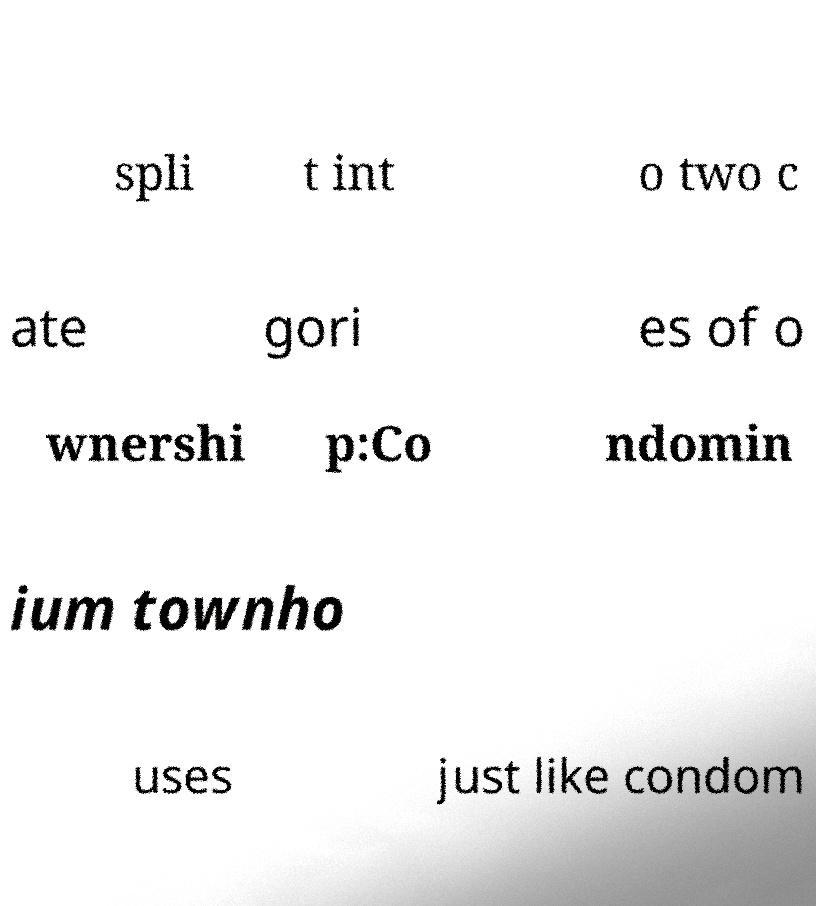Could you assist in decoding the text presented in this image and type it out clearly? spli t int o two c ate gori es of o wnershi p:Co ndomin ium townho uses just like condom 